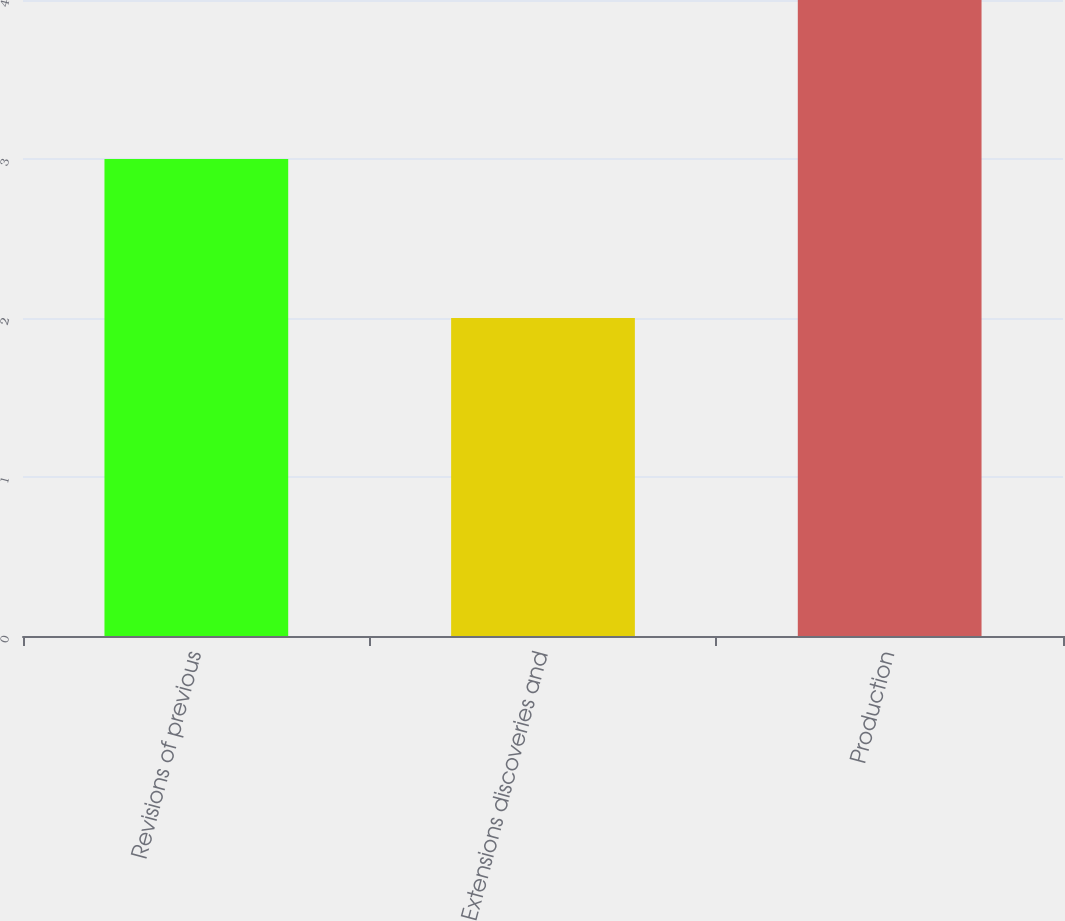Convert chart to OTSL. <chart><loc_0><loc_0><loc_500><loc_500><bar_chart><fcel>Revisions of previous<fcel>Extensions discoveries and<fcel>Production<nl><fcel>3<fcel>2<fcel>4<nl></chart> 